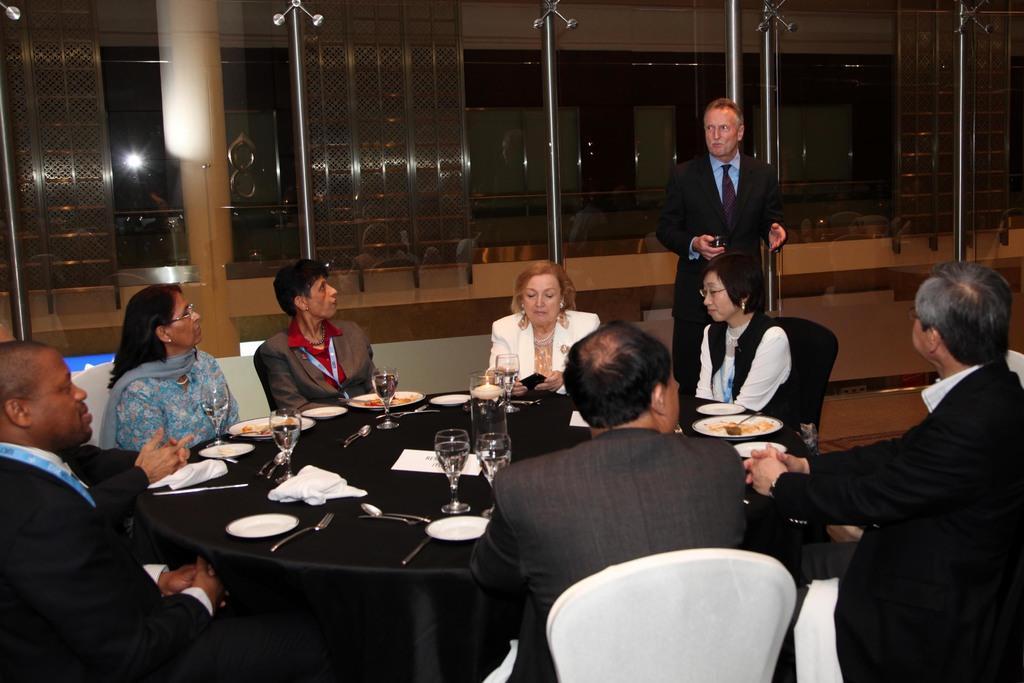Describe this image in one or two sentences. As we can see in the image there is a wall, window, few people sitting on chairs and there is a table over here and on table there are plates, spoons and glasses. 